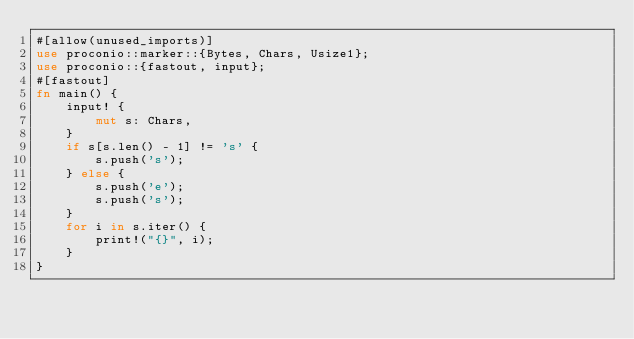<code> <loc_0><loc_0><loc_500><loc_500><_Rust_>#[allow(unused_imports)]
use proconio::marker::{Bytes, Chars, Usize1};
use proconio::{fastout, input};
#[fastout]
fn main() {
    input! {
        mut s: Chars,
    }
    if s[s.len() - 1] != 's' {
        s.push('s');
    } else {
        s.push('e');
        s.push('s');
    }
    for i in s.iter() {
        print!("{}", i);
    }
}
</code> 